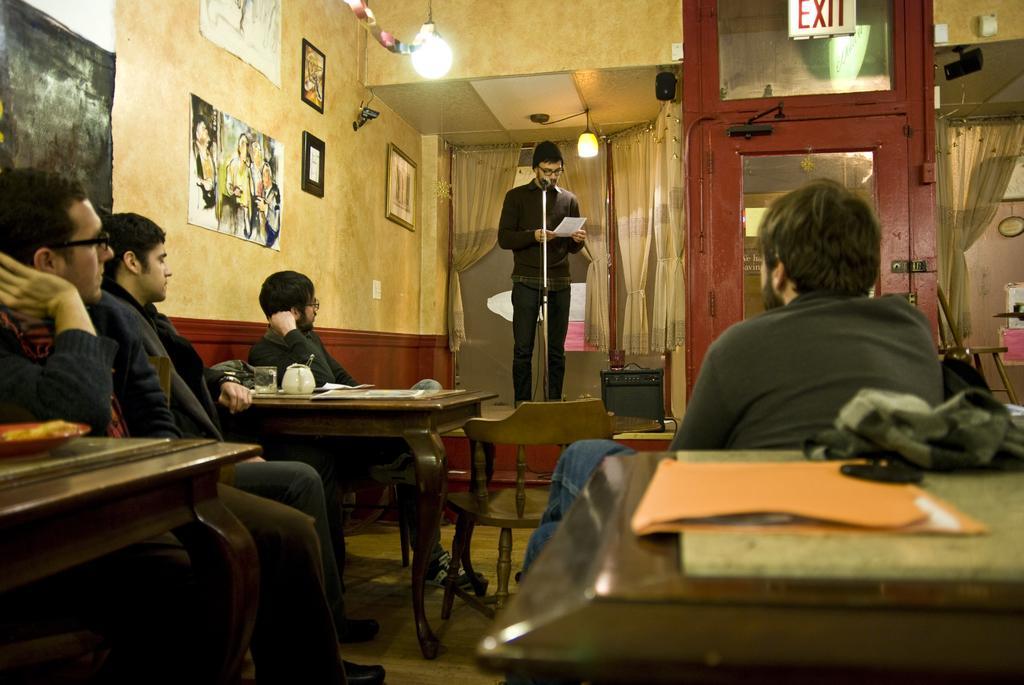Describe this image in one or two sentences. On the background we can see door, curtains, photo frames over a wall. We can see one man standing in front of a mike and he is holding a paper in his hand. We can see four persons sitting on chairs in front of a table and on the table we can see file, cap, papers and glass. This is a floor. 